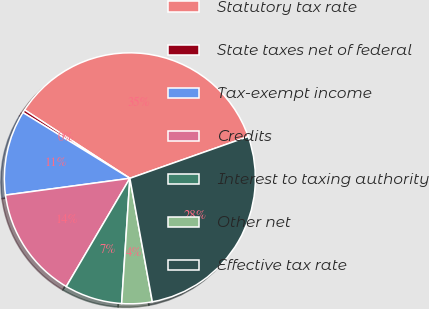Convert chart. <chart><loc_0><loc_0><loc_500><loc_500><pie_chart><fcel>Statutory tax rate<fcel>State taxes net of federal<fcel>Tax-exempt income<fcel>Credits<fcel>Interest to taxing authority<fcel>Other net<fcel>Effective tax rate<nl><fcel>35.43%<fcel>0.4%<fcel>10.91%<fcel>14.41%<fcel>7.41%<fcel>3.91%<fcel>27.53%<nl></chart> 